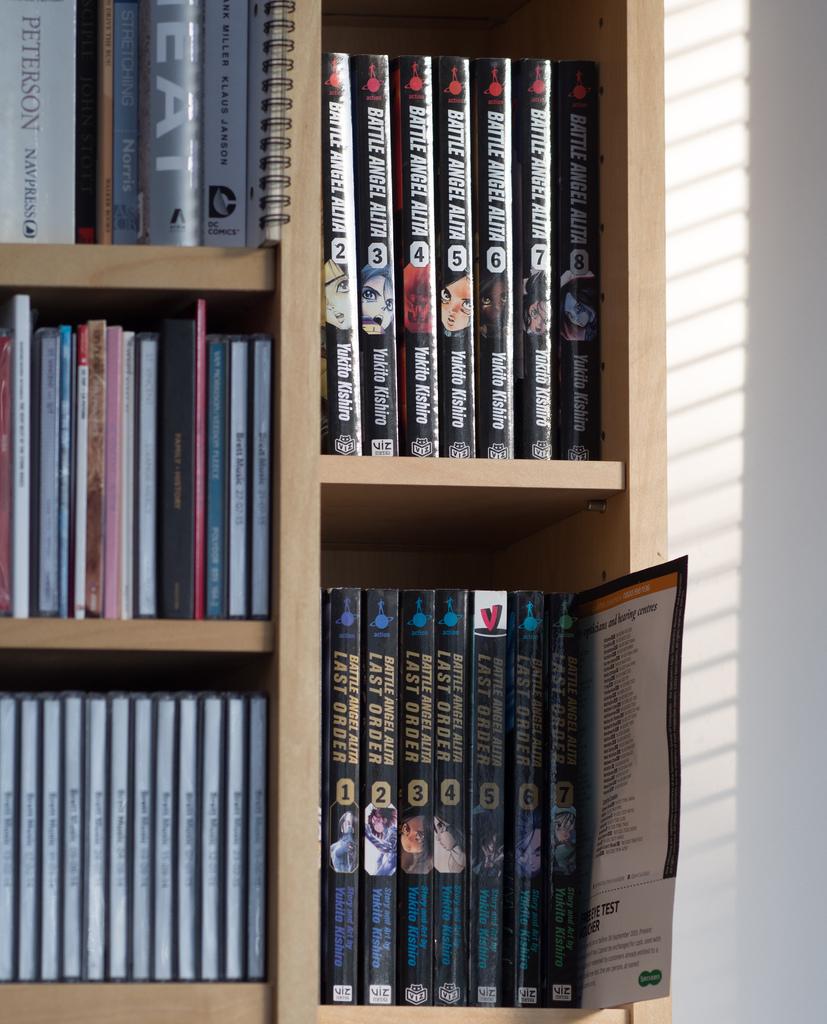What is the title of the series on the top right shelf?
Make the answer very short. Battle angel alita. Whats number book is the series of the top right book?
Provide a succinct answer. 8. 